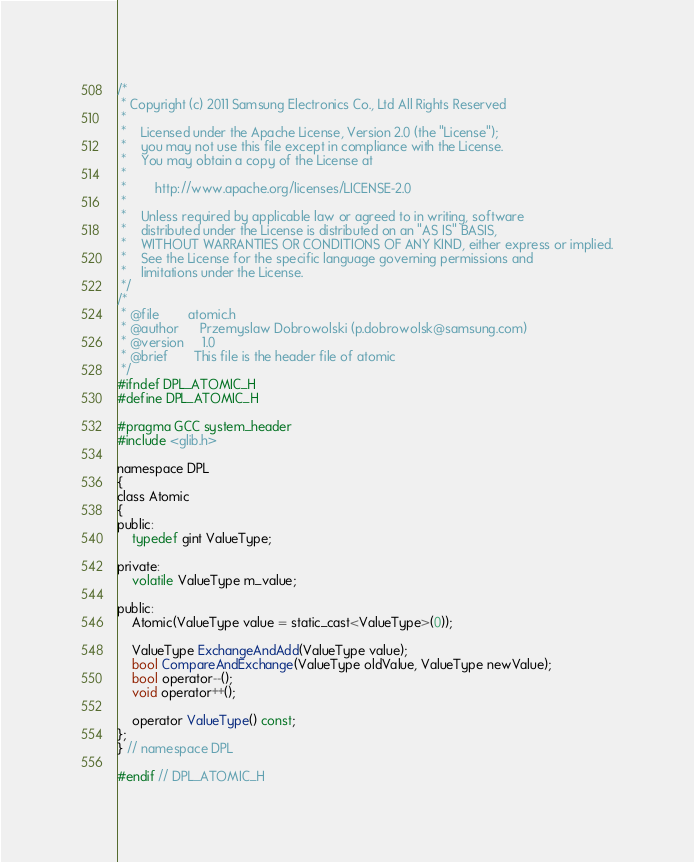Convert code to text. <code><loc_0><loc_0><loc_500><loc_500><_C_>/*
 * Copyright (c) 2011 Samsung Electronics Co., Ltd All Rights Reserved
 *
 *    Licensed under the Apache License, Version 2.0 (the "License");
 *    you may not use this file except in compliance with the License.
 *    You may obtain a copy of the License at
 *
 *        http://www.apache.org/licenses/LICENSE-2.0
 *
 *    Unless required by applicable law or agreed to in writing, software
 *    distributed under the License is distributed on an "AS IS" BASIS,
 *    WITHOUT WARRANTIES OR CONDITIONS OF ANY KIND, either express or implied.
 *    See the License for the specific language governing permissions and
 *    limitations under the License.
 */
/*
 * @file        atomic.h
 * @author      Przemyslaw Dobrowolski (p.dobrowolsk@samsung.com)
 * @version     1.0
 * @brief       This file is the header file of atomic
 */
#ifndef DPL_ATOMIC_H
#define DPL_ATOMIC_H

#pragma GCC system_header
#include <glib.h>

namespace DPL
{
class Atomic
{
public:
    typedef gint ValueType;

private:
    volatile ValueType m_value;

public:
    Atomic(ValueType value = static_cast<ValueType>(0));

    ValueType ExchangeAndAdd(ValueType value);
    bool CompareAndExchange(ValueType oldValue, ValueType newValue);
    bool operator--();
    void operator++();

    operator ValueType() const;
};
} // namespace DPL

#endif // DPL_ATOMIC_H
</code> 